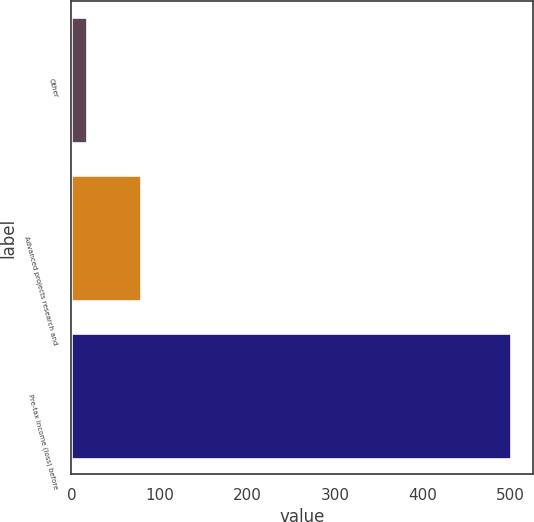<chart> <loc_0><loc_0><loc_500><loc_500><bar_chart><fcel>Other<fcel>Advanced projects research and<fcel>Pre-tax income (loss) before<nl><fcel>18<fcel>79<fcel>501<nl></chart> 